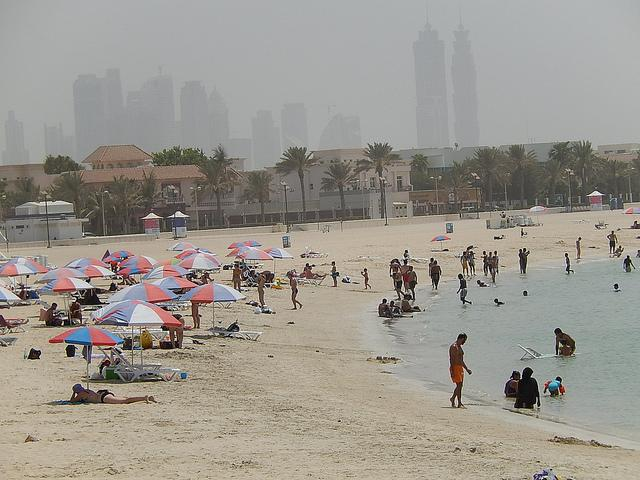Why are all the umbrellas there? sun protection 